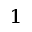<formula> <loc_0><loc_0><loc_500><loc_500>^ { 1 }</formula> 